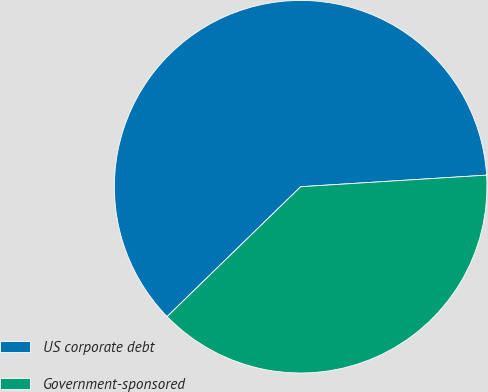<chart> <loc_0><loc_0><loc_500><loc_500><pie_chart><fcel>US corporate debt<fcel>Government-sponsored<nl><fcel>61.29%<fcel>38.71%<nl></chart> 